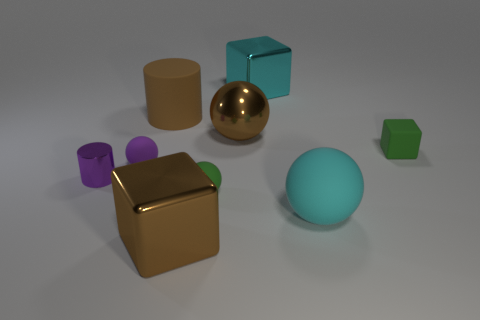Add 1 small yellow rubber spheres. How many objects exist? 10 Subtract all red spheres. Subtract all blue blocks. How many spheres are left? 4 Subtract all cubes. How many objects are left? 6 Subtract all yellow cubes. Subtract all small purple shiny cylinders. How many objects are left? 8 Add 7 cyan metal blocks. How many cyan metal blocks are left? 8 Add 1 big gray metallic things. How many big gray metallic things exist? 1 Subtract 1 green spheres. How many objects are left? 8 